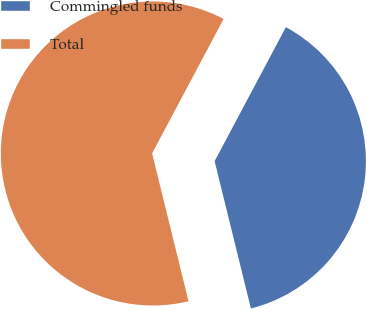Convert chart to OTSL. <chart><loc_0><loc_0><loc_500><loc_500><pie_chart><fcel>Commingled funds<fcel>Total<nl><fcel>38.38%<fcel>61.62%<nl></chart> 